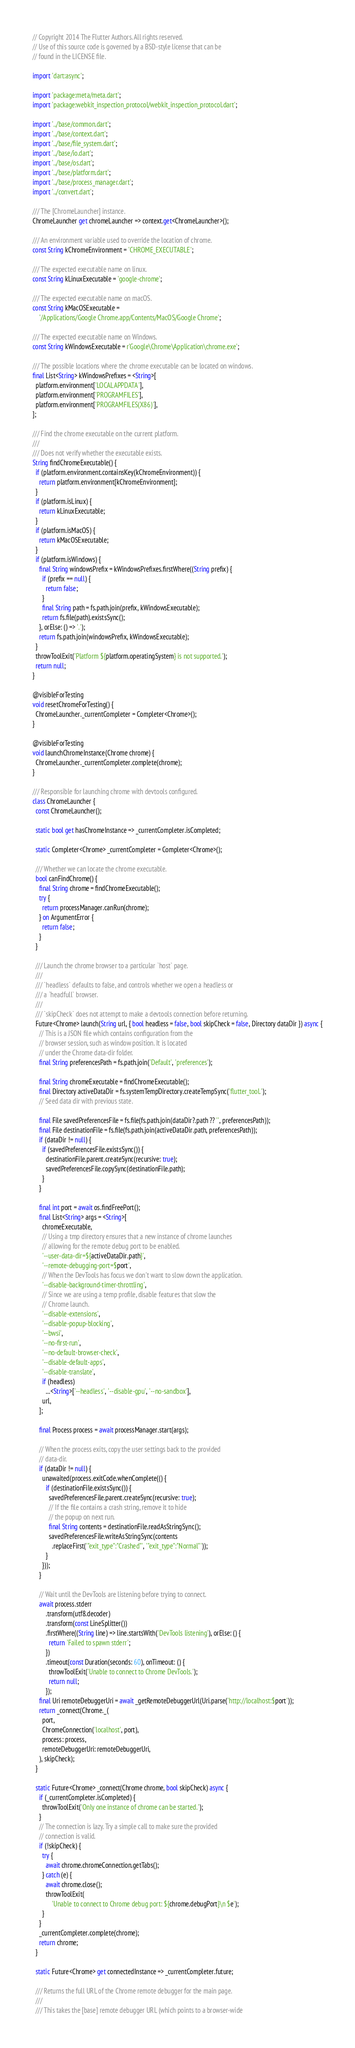<code> <loc_0><loc_0><loc_500><loc_500><_Dart_>// Copyright 2014 The Flutter Authors. All rights reserved.
// Use of this source code is governed by a BSD-style license that can be
// found in the LICENSE file.

import 'dart:async';

import 'package:meta/meta.dart';
import 'package:webkit_inspection_protocol/webkit_inspection_protocol.dart';

import '../base/common.dart';
import '../base/context.dart';
import '../base/file_system.dart';
import '../base/io.dart';
import '../base/os.dart';
import '../base/platform.dart';
import '../base/process_manager.dart';
import '../convert.dart';

/// The [ChromeLauncher] instance.
ChromeLauncher get chromeLauncher => context.get<ChromeLauncher>();

/// An environment variable used to override the location of chrome.
const String kChromeEnvironment = 'CHROME_EXECUTABLE';

/// The expected executable name on linux.
const String kLinuxExecutable = 'google-chrome';

/// The expected executable name on macOS.
const String kMacOSExecutable =
    '/Applications/Google Chrome.app/Contents/MacOS/Google Chrome';

/// The expected executable name on Windows.
const String kWindowsExecutable = r'Google\Chrome\Application\chrome.exe';

/// The possible locations where the chrome executable can be located on windows.
final List<String> kWindowsPrefixes = <String>[
  platform.environment['LOCALAPPDATA'],
  platform.environment['PROGRAMFILES'],
  platform.environment['PROGRAMFILES(X86)'],
];

/// Find the chrome executable on the current platform.
///
/// Does not verify whether the executable exists.
String findChromeExecutable() {
  if (platform.environment.containsKey(kChromeEnvironment)) {
    return platform.environment[kChromeEnvironment];
  }
  if (platform.isLinux) {
    return kLinuxExecutable;
  }
  if (platform.isMacOS) {
    return kMacOSExecutable;
  }
  if (platform.isWindows) {
    final String windowsPrefix = kWindowsPrefixes.firstWhere((String prefix) {
      if (prefix == null) {
        return false;
      }
      final String path = fs.path.join(prefix, kWindowsExecutable);
      return fs.file(path).existsSync();
    }, orElse: () => '.');
    return fs.path.join(windowsPrefix, kWindowsExecutable);
  }
  throwToolExit('Platform ${platform.operatingSystem} is not supported.');
  return null;
}

@visibleForTesting
void resetChromeForTesting() {
  ChromeLauncher._currentCompleter = Completer<Chrome>();
}

@visibleForTesting
void launchChromeInstance(Chrome chrome) {
  ChromeLauncher._currentCompleter.complete(chrome);
}

/// Responsible for launching chrome with devtools configured.
class ChromeLauncher {
  const ChromeLauncher();

  static bool get hasChromeInstance => _currentCompleter.isCompleted;

  static Completer<Chrome> _currentCompleter = Completer<Chrome>();

  /// Whether we can locate the chrome executable.
  bool canFindChrome() {
    final String chrome = findChromeExecutable();
    try {
      return processManager.canRun(chrome);
    } on ArgumentError {
      return false;
    }
  }

  /// Launch the chrome browser to a particular `host` page.
  ///
  /// `headless` defaults to false, and controls whether we open a headless or
  /// a `headfull` browser.
  ///
  /// `skipCheck` does not attempt to make a devtools connection before returning.
  Future<Chrome> launch(String url, { bool headless = false, bool skipCheck = false, Directory dataDir }) async {
    // This is a JSON file which contains configuration from the
    // browser session, such as window position. It is located
    // under the Chrome data-dir folder.
    final String preferencesPath = fs.path.join('Default', 'preferences');

    final String chromeExecutable = findChromeExecutable();
    final Directory activeDataDir = fs.systemTempDirectory.createTempSync('flutter_tool.');
    // Seed data dir with previous state.

    final File savedPreferencesFile = fs.file(fs.path.join(dataDir?.path ?? '', preferencesPath));
    final File destinationFile = fs.file(fs.path.join(activeDataDir.path, preferencesPath));
    if (dataDir != null) {
      if (savedPreferencesFile.existsSync()) {
        destinationFile.parent.createSync(recursive: true);
        savedPreferencesFile.copySync(destinationFile.path);
      }
    }

    final int port = await os.findFreePort();
    final List<String> args = <String>[
      chromeExecutable,
      // Using a tmp directory ensures that a new instance of chrome launches
      // allowing for the remote debug port to be enabled.
      '--user-data-dir=${activeDataDir.path}',
      '--remote-debugging-port=$port',
      // When the DevTools has focus we don't want to slow down the application.
      '--disable-background-timer-throttling',
      // Since we are using a temp profile, disable features that slow the
      // Chrome launch.
      '--disable-extensions',
      '--disable-popup-blocking',
      '--bwsi',
      '--no-first-run',
      '--no-default-browser-check',
      '--disable-default-apps',
      '--disable-translate',
      if (headless)
        ...<String>['--headless', '--disable-gpu', '--no-sandbox'],
      url,
    ];

    final Process process = await processManager.start(args);

    // When the process exits, copy the user settings back to the provided
    // data-dir.
    if (dataDir != null) {
      unawaited(process.exitCode.whenComplete(() {
        if (destinationFile.existsSync()) {
          savedPreferencesFile.parent.createSync(recursive: true);
          // If the file contains a crash string, remove it to hide
          // the popup on next run.
          final String contents = destinationFile.readAsStringSync();
          savedPreferencesFile.writeAsStringSync(contents
            .replaceFirst('"exit_type":"Crashed"', '"exit_type":"Normal"'));
        }
      }));
    }

    // Wait until the DevTools are listening before trying to connect.
    await process.stderr
        .transform(utf8.decoder)
        .transform(const LineSplitter())
        .firstWhere((String line) => line.startsWith('DevTools listening'), orElse: () {
          return 'Failed to spawn stderr';
        })
        .timeout(const Duration(seconds: 60), onTimeout: () {
          throwToolExit('Unable to connect to Chrome DevTools.');
          return null;
        });
    final Uri remoteDebuggerUri = await _getRemoteDebuggerUrl(Uri.parse('http://localhost:$port'));
    return _connect(Chrome._(
      port,
      ChromeConnection('localhost', port),
      process: process,
      remoteDebuggerUri: remoteDebuggerUri,
    ), skipCheck);
  }

  static Future<Chrome> _connect(Chrome chrome, bool skipCheck) async {
    if (_currentCompleter.isCompleted) {
      throwToolExit('Only one instance of chrome can be started.');
    }
    // The connection is lazy. Try a simple call to make sure the provided
    // connection is valid.
    if (!skipCheck) {
      try {
        await chrome.chromeConnection.getTabs();
      } catch (e) {
        await chrome.close();
        throwToolExit(
            'Unable to connect to Chrome debug port: ${chrome.debugPort}\n $e');
      }
    }
    _currentCompleter.complete(chrome);
    return chrome;
  }

  static Future<Chrome> get connectedInstance => _currentCompleter.future;

  /// Returns the full URL of the Chrome remote debugger for the main page.
  ///
  /// This takes the [base] remote debugger URL (which points to a browser-wide</code> 